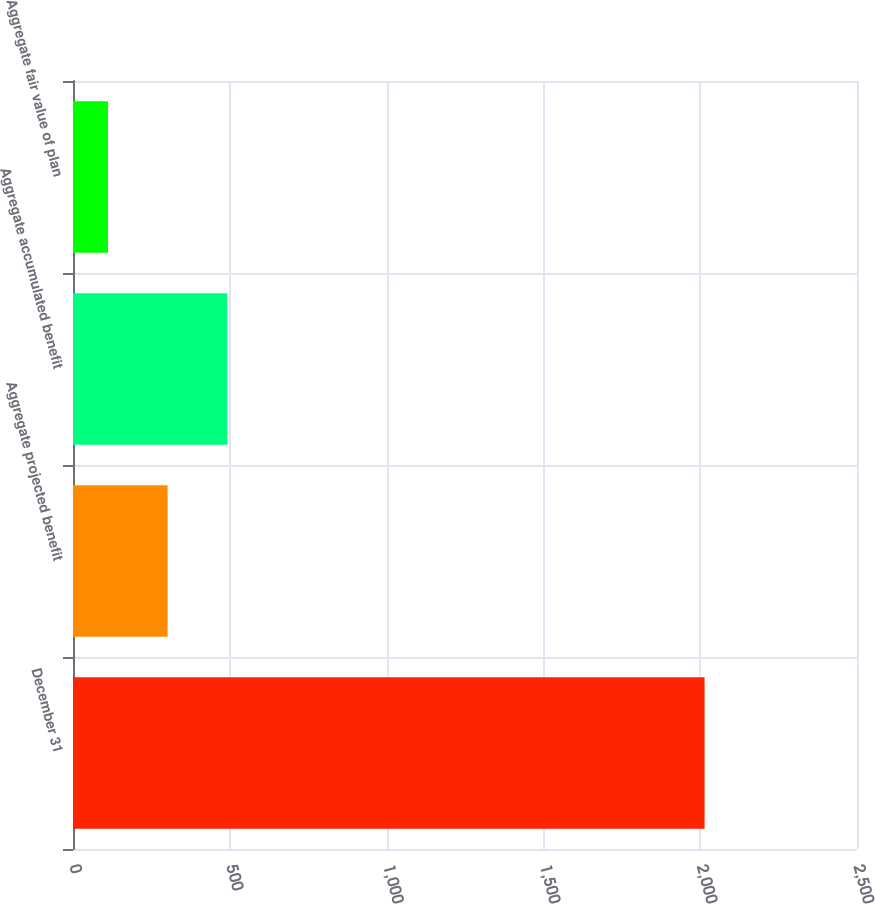Convert chart. <chart><loc_0><loc_0><loc_500><loc_500><bar_chart><fcel>December 31<fcel>Aggregate projected benefit<fcel>Aggregate accumulated benefit<fcel>Aggregate fair value of plan<nl><fcel>2014<fcel>301.75<fcel>492<fcel>111.5<nl></chart> 